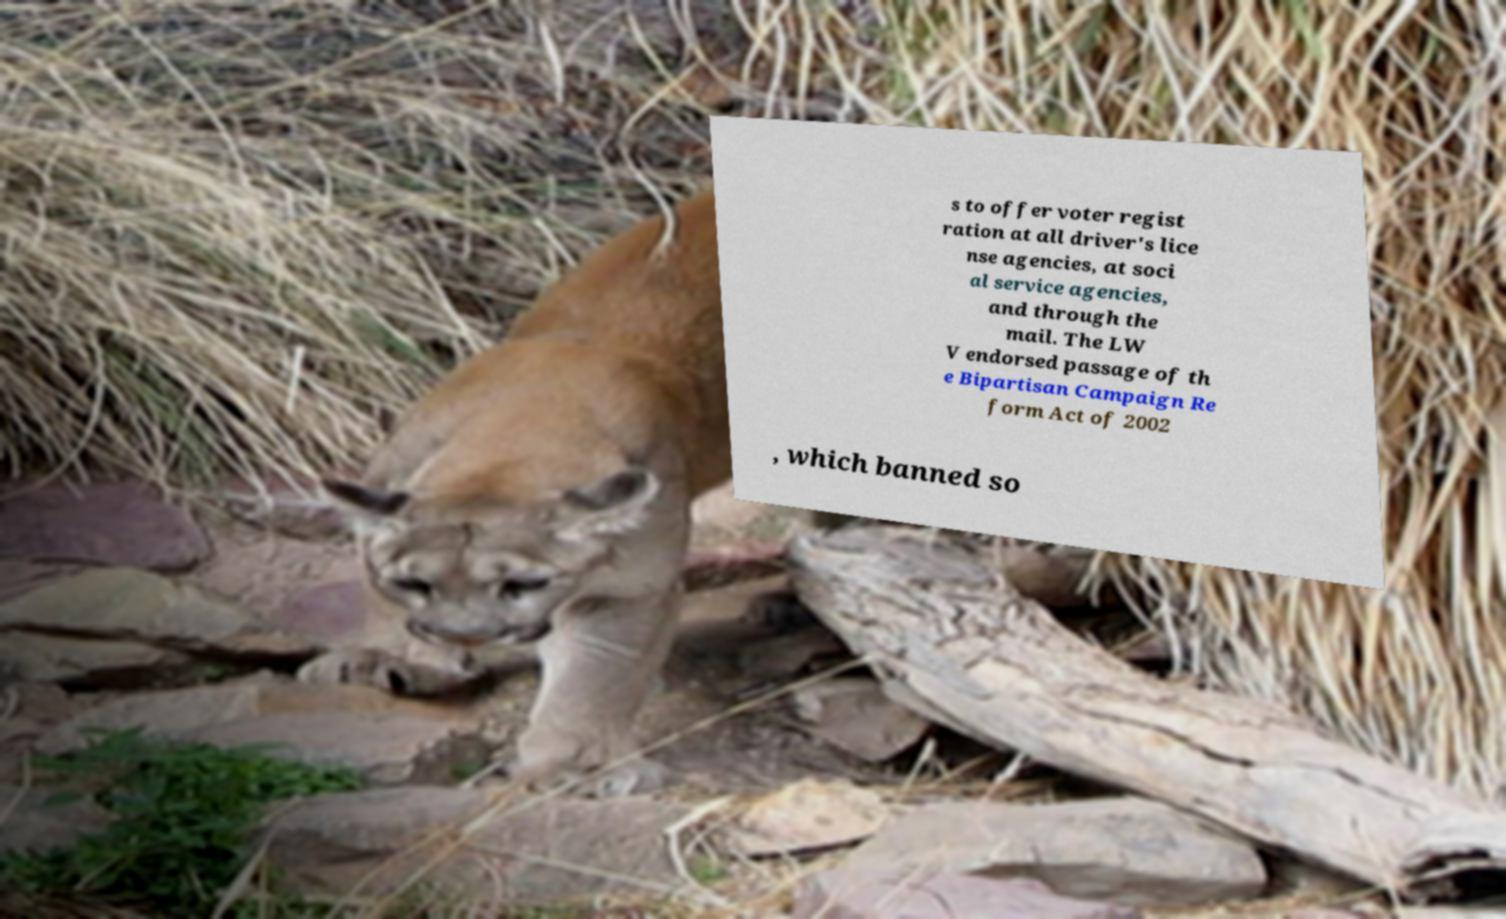Could you extract and type out the text from this image? s to offer voter regist ration at all driver's lice nse agencies, at soci al service agencies, and through the mail. The LW V endorsed passage of th e Bipartisan Campaign Re form Act of 2002 , which banned so 